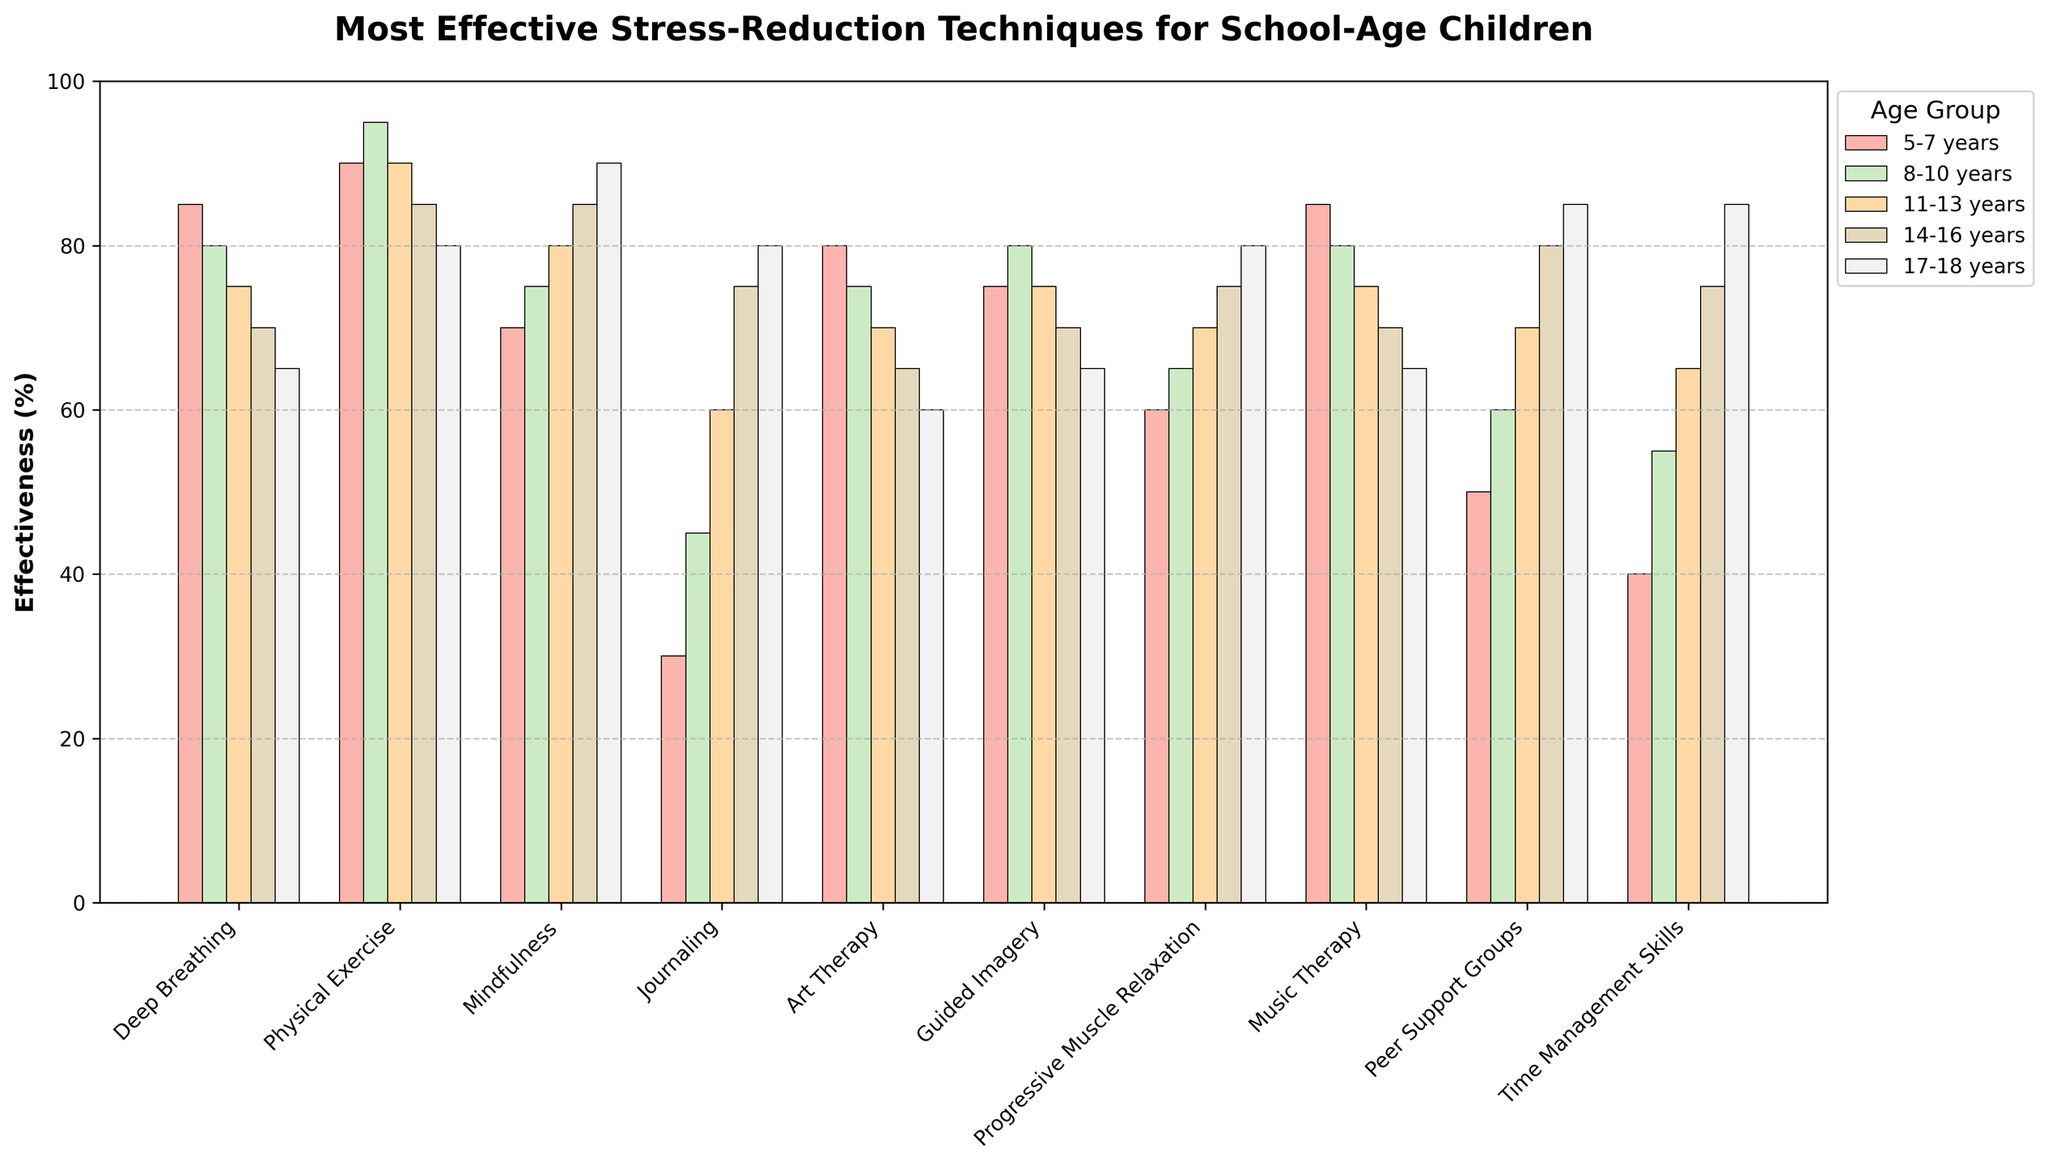what is the most effective stress-reduction technique for the 5-7 age group? The highest bar in the 5-7 age group corresponds to Physical Exercise with 90% effectiveness. Therefore, the most effective technique for this group is Physical Exercise
Answer: Physical Exercise Comparing Deep Breathing and Mindfulness, which technique shows greater effectiveness in the 17-18 age group? The bar for Deep Breathing in the 17-18 age group is at 65%, while the bar for Mindfulness is at 90%. Thus, Mindfulness shows greater effectiveness for this age group.
Answer: Mindfulness What is the average effectiveness of Guided Imagery across all age groups? To find the average effectiveness, we sum the values for Guided Imagery across all age groups and divide by the number of groups: (75 + 80 + 75 + 70 + 65) = 365, and 365 / 5 = 73%
Answer: 73% Which technique has the smallest discrepancy in effectiveness between the 5-7 years and 17-18 years age groups? By visually inspecting the bars for all techniques in the 5-7 and 17-18 age groups, Guided Imagery has the closest values, with 75% in the 5-7 group and 65% in the 17-18 group, resulting in a discrepancy of 10%
Answer: Guided Imagery Are there any techniques that show a consistent increase in effectiveness from the 5-7 age group to the 17-18 age group? By visually inspecting the trend, Mindfulness shows a consistent increase from 70% in the 5-7 age group to 90% in the 17-18 age group
Answer: Mindfulness What is the overall trend observed for Time Management Skills from the youngest to the oldest age group? Time Management Skills bars show an increasing trend from 40% in the 5-7 age group to 85% in the 17-18 age group
Answer: Increasing Trend Combining Deep Breathing and Physical Exercise, which age group shows the highest combined effectiveness? Summing Deep Breathing and Physical Exercise for each age group: 5-7 (85+90=175), 8-10 (80+95=175), 11-13 (75+90=165), 14-16 (70+85=155), 17-18 (65+80=145). The highest combined effectiveness is seen in the 5-7 and 8-10 age groups with 175%
Answer: 5-7 and 8-10 years Which age group has the highest effectiveness for Peer Support Groups? The highest bar for Peer Support Groups is in the 17-18 age group at 85%
Answer: 17-18 years Between the 11-13 and 14-16 age groups, which has a greater median effectiveness for all techniques? For 11-13 years: [75, 90, 80, 60, 70, 75, 70, 75, 70, 65], sorted: [60, 65, 70, 70, 70, 75, 75, 75, 80, 90], median = (70+75)/2 = 72.5. For 14-16 years: [70, 85, 85, 75, 65, 70, 75, 70, 80, 75], sorted: [65, 70, 70, 70, 75, 75, 75, 80, 85, 85], median = (75+75)/2 = 75. So, the 14-16 years group has the greater median effectiveness
Answer: 14-16 years 